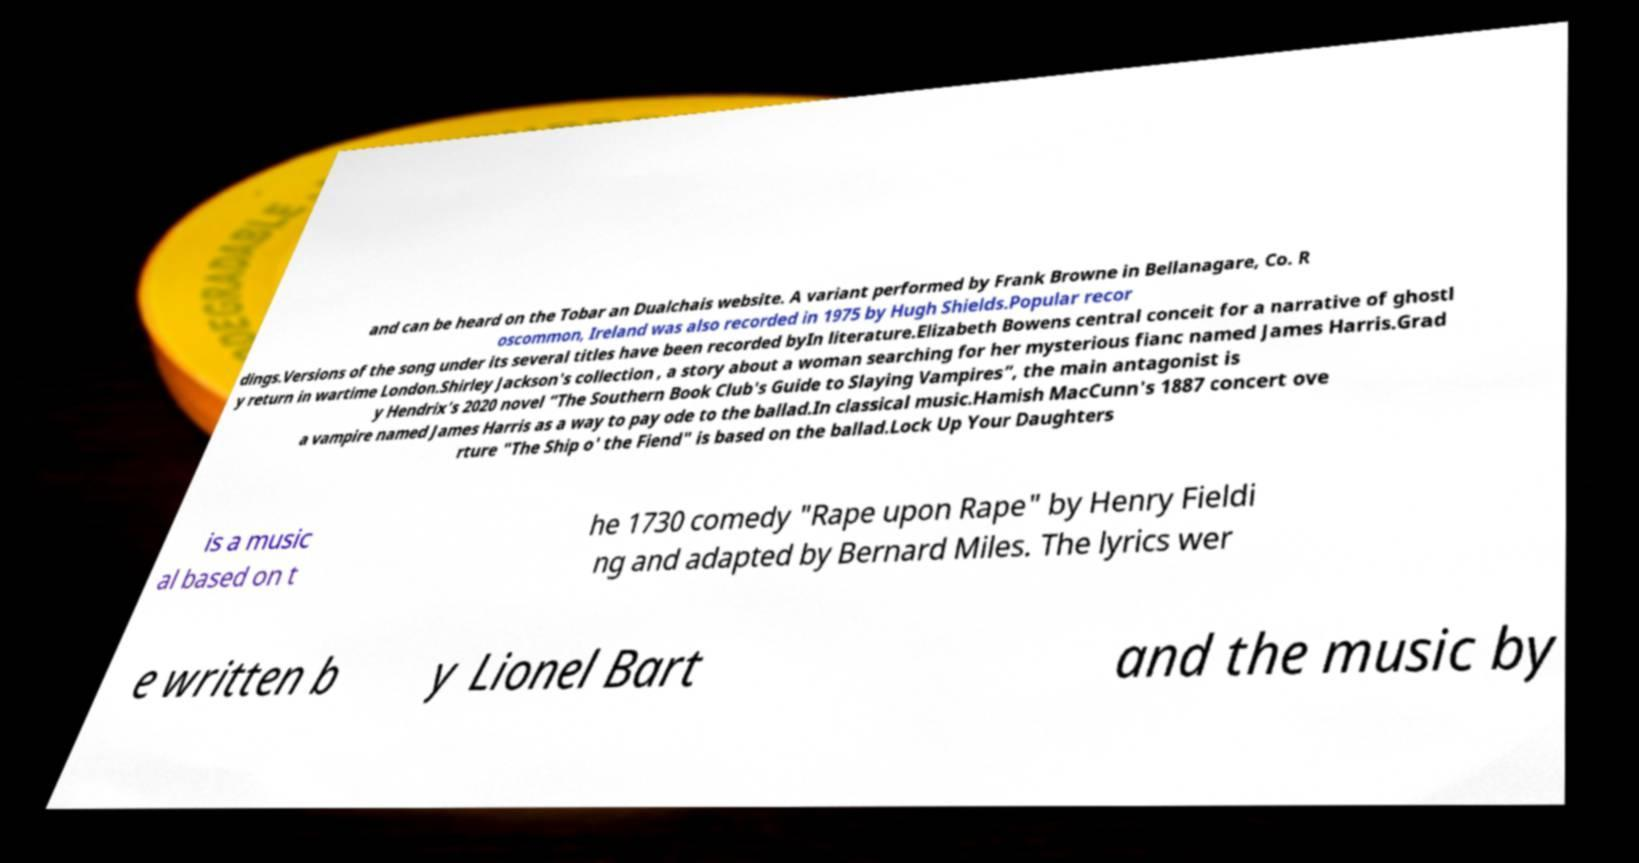I need the written content from this picture converted into text. Can you do that? and can be heard on the Tobar an Dualchais website. A variant performed by Frank Browne in Bellanagare, Co. R oscommon, Ireland was also recorded in 1975 by Hugh Shields.Popular recor dings.Versions of the song under its several titles have been recorded byIn literature.Elizabeth Bowens central conceit for a narrative of ghostl y return in wartime London.Shirley Jackson's collection , a story about a woman searching for her mysterious fianc named James Harris.Grad y Hendrix’s 2020 novel “The Southern Book Club's Guide to Slaying Vampires”, the main antagonist is a vampire named James Harris as a way to pay ode to the ballad.In classical music.Hamish MacCunn's 1887 concert ove rture "The Ship o' the Fiend" is based on the ballad.Lock Up Your Daughters is a music al based on t he 1730 comedy "Rape upon Rape" by Henry Fieldi ng and adapted by Bernard Miles. The lyrics wer e written b y Lionel Bart and the music by 